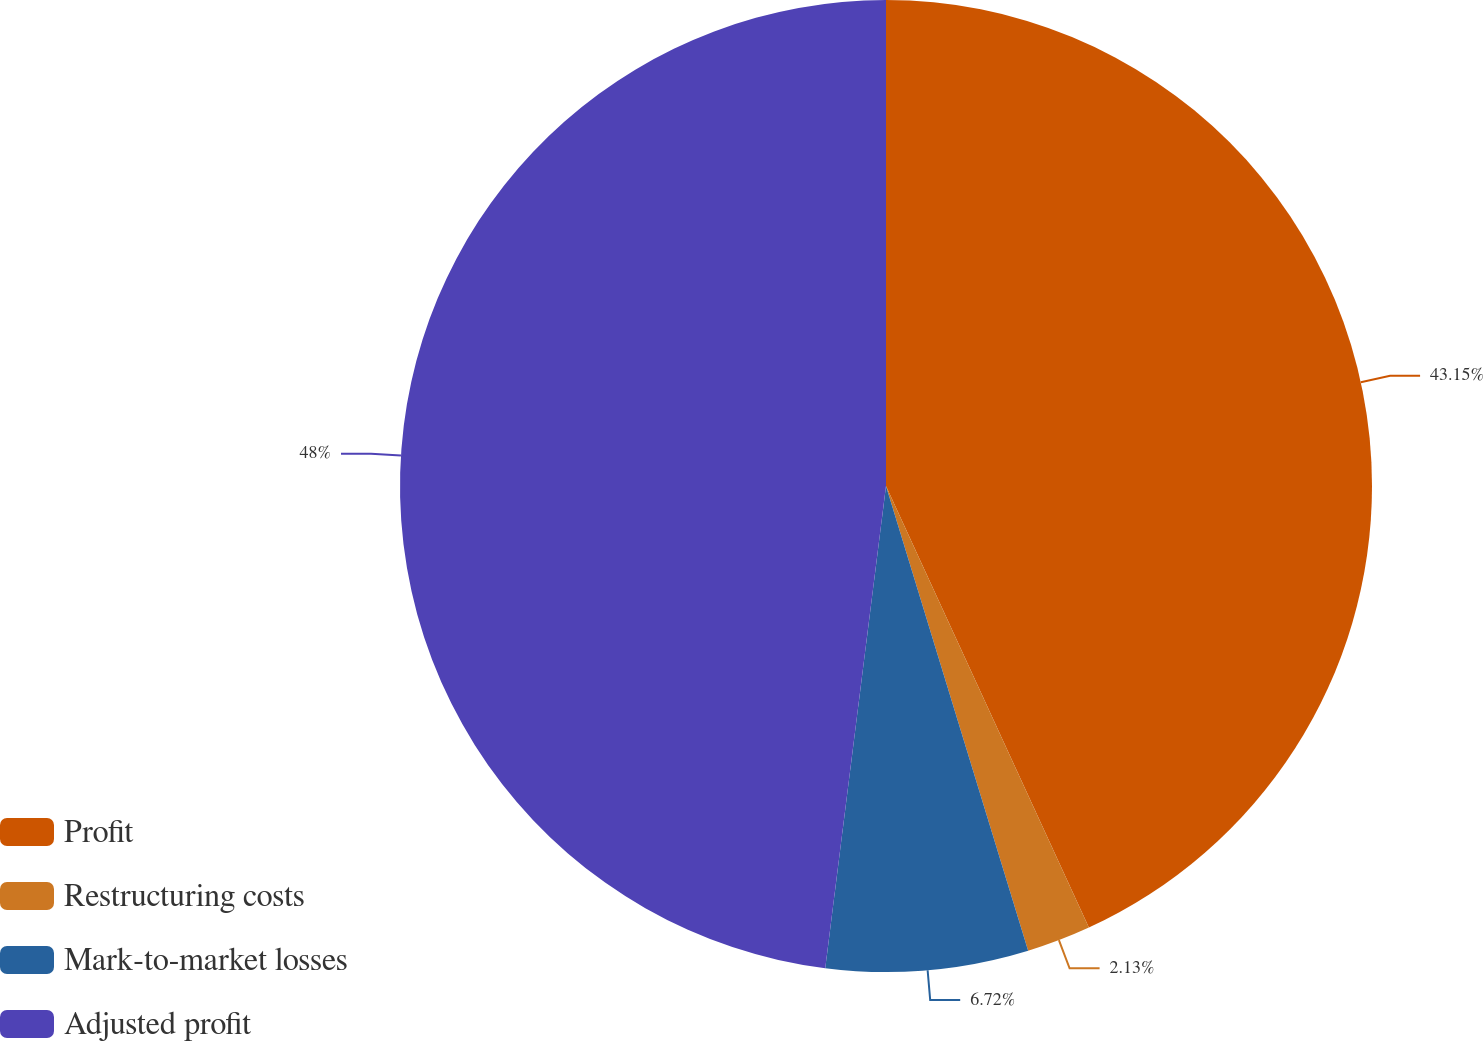<chart> <loc_0><loc_0><loc_500><loc_500><pie_chart><fcel>Profit<fcel>Restructuring costs<fcel>Mark-to-market losses<fcel>Adjusted profit<nl><fcel>43.15%<fcel>2.13%<fcel>6.72%<fcel>48.01%<nl></chart> 